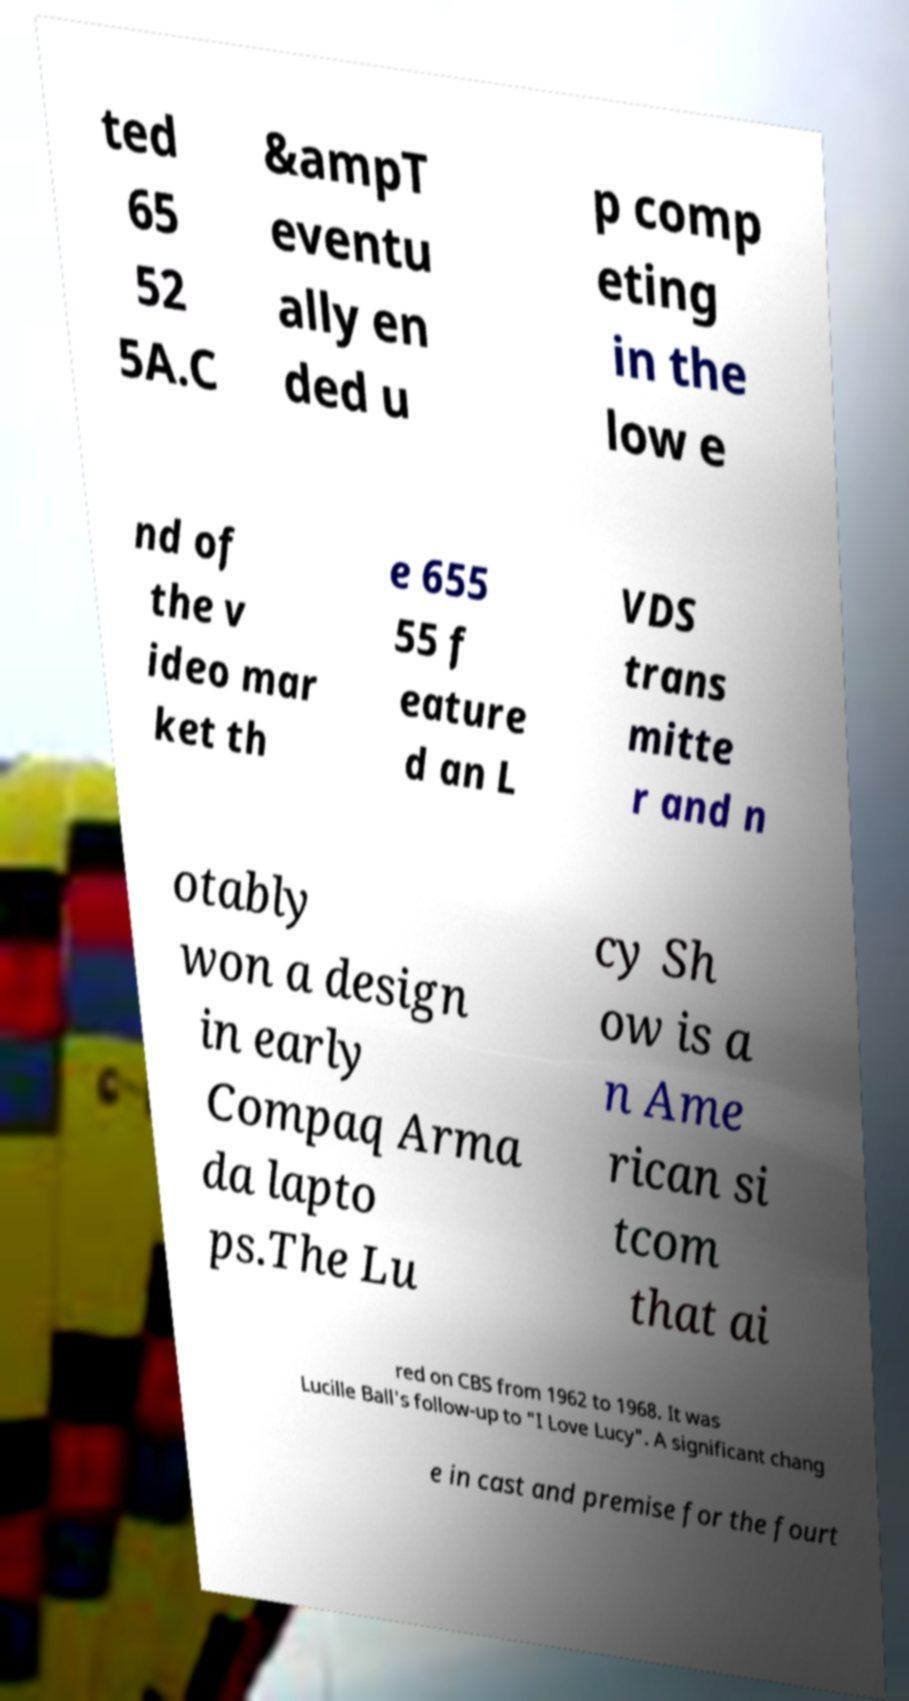I need the written content from this picture converted into text. Can you do that? ted 65 52 5A.C &ampT eventu ally en ded u p comp eting in the low e nd of the v ideo mar ket th e 655 55 f eature d an L VDS trans mitte r and n otably won a design in early Compaq Arma da lapto ps.The Lu cy Sh ow is a n Ame rican si tcom that ai red on CBS from 1962 to 1968. It was Lucille Ball's follow-up to "I Love Lucy". A significant chang e in cast and premise for the fourt 